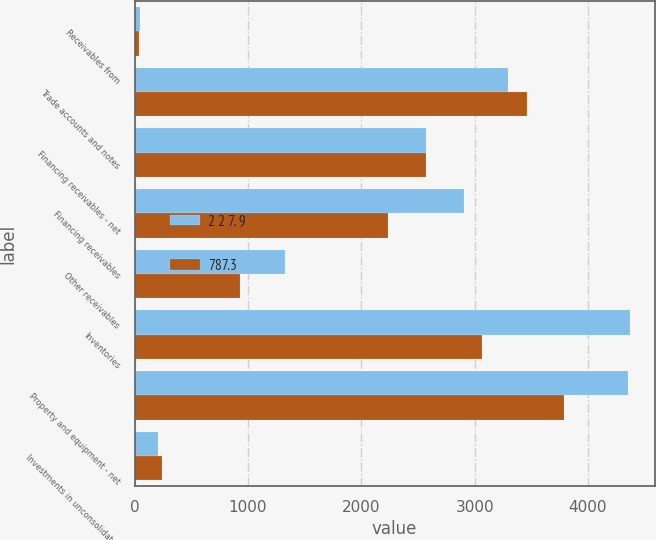Convert chart. <chart><loc_0><loc_0><loc_500><loc_500><stacked_bar_chart><ecel><fcel>Receivables from<fcel>Trade accounts and notes<fcel>Financing receivables - net<fcel>Financing receivables<fcel>Other receivables<fcel>Inventories<fcel>Property and equipment - net<fcel>Investments in unconsolidated<nl><fcel>2 2 7. 9<fcel>48<fcel>3294.5<fcel>2571.65<fcel>2905<fcel>1330.6<fcel>4370.6<fcel>4352.3<fcel>201.7<nl><fcel>787.3<fcel>38.8<fcel>3464.2<fcel>2571.65<fcel>2238.3<fcel>925.6<fcel>3063<fcel>3790.7<fcel>244.5<nl></chart> 